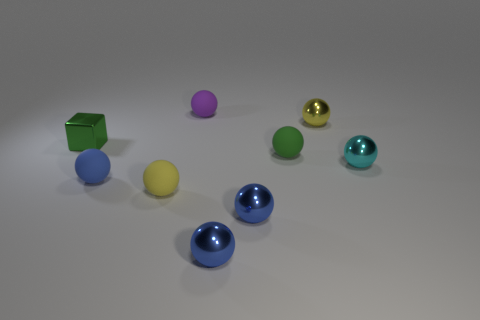Subtract all brown cubes. How many blue spheres are left? 3 Subtract all purple spheres. How many spheres are left? 7 Subtract all blue balls. How many balls are left? 5 Subtract all red spheres. Subtract all brown cylinders. How many spheres are left? 8 Add 1 purple things. How many objects exist? 10 Subtract all cubes. How many objects are left? 8 Subtract 0 brown balls. How many objects are left? 9 Subtract all cyan matte balls. Subtract all small shiny spheres. How many objects are left? 5 Add 2 small cyan spheres. How many small cyan spheres are left? 3 Add 7 cubes. How many cubes exist? 8 